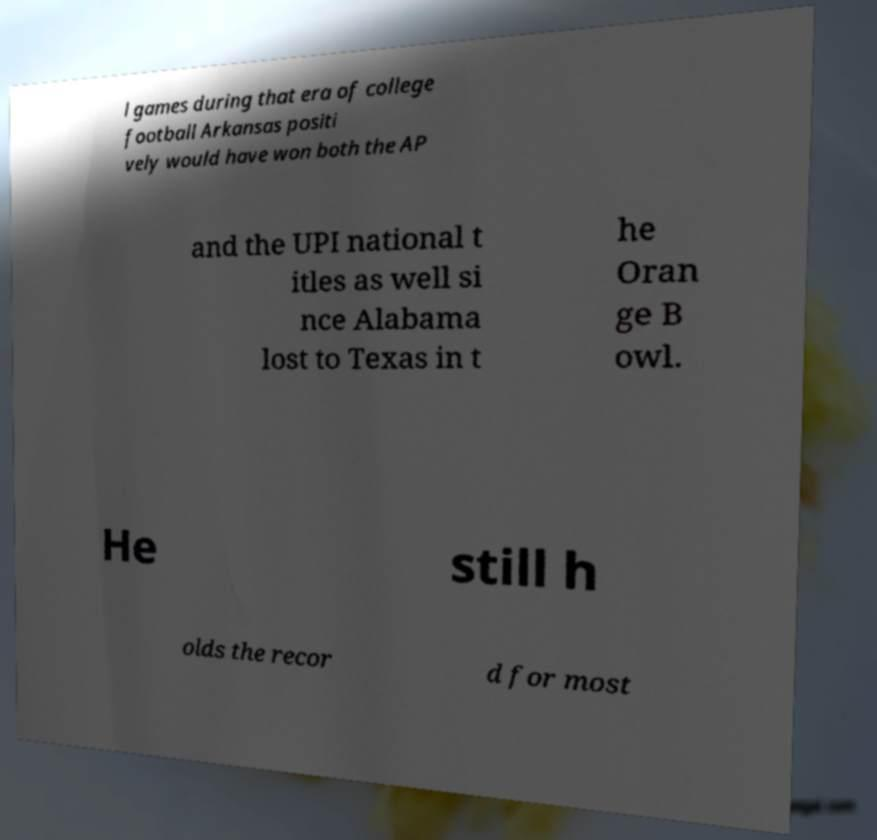For documentation purposes, I need the text within this image transcribed. Could you provide that? l games during that era of college football Arkansas positi vely would have won both the AP and the UPI national t itles as well si nce Alabama lost to Texas in t he Oran ge B owl. He still h olds the recor d for most 